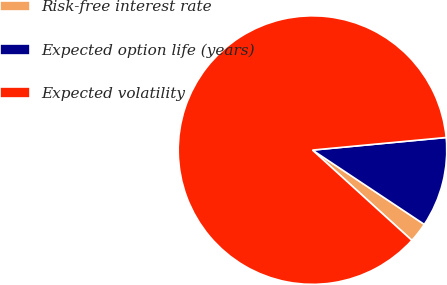Convert chart to OTSL. <chart><loc_0><loc_0><loc_500><loc_500><pie_chart><fcel>Risk-free interest rate<fcel>Expected option life (years)<fcel>Expected volatility<nl><fcel>2.4%<fcel>10.83%<fcel>86.76%<nl></chart> 